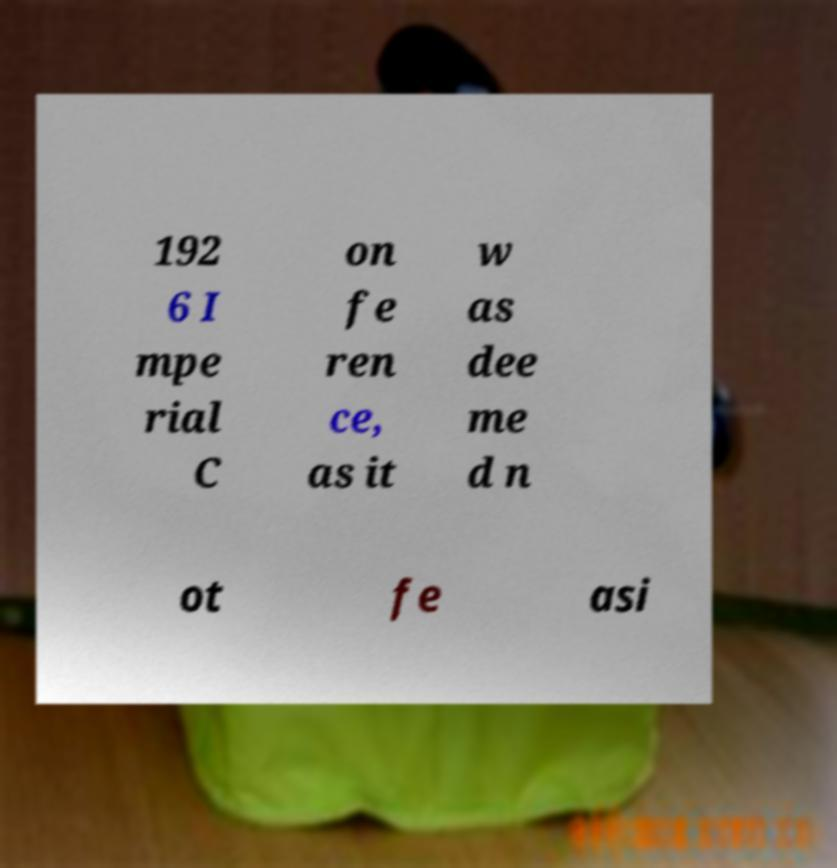Please read and relay the text visible in this image. What does it say? 192 6 I mpe rial C on fe ren ce, as it w as dee me d n ot fe asi 